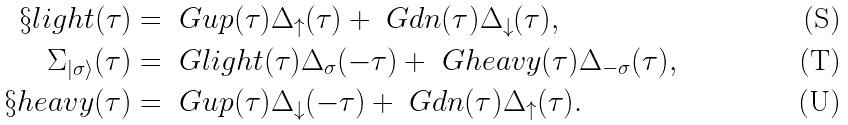<formula> <loc_0><loc_0><loc_500><loc_500>\S l i g h t ( \tau ) & = \ G u p ( \tau ) \Delta _ { \uparrow } ( \tau ) + \ G d n ( \tau ) \Delta _ { \downarrow } ( \tau ) , \\ \Sigma _ { | \sigma \rangle } ( \tau ) & = \ G l i g h t ( \tau ) \Delta _ { \sigma } ( - \tau ) + \ G h e a v y ( \tau ) \Delta _ { - \sigma } ( \tau ) , \\ \S h e a v y ( \tau ) & = \ G u p ( \tau ) \Delta _ { \downarrow } ( - \tau ) + \ G d n ( \tau ) \Delta _ { \uparrow } ( \tau ) .</formula> 